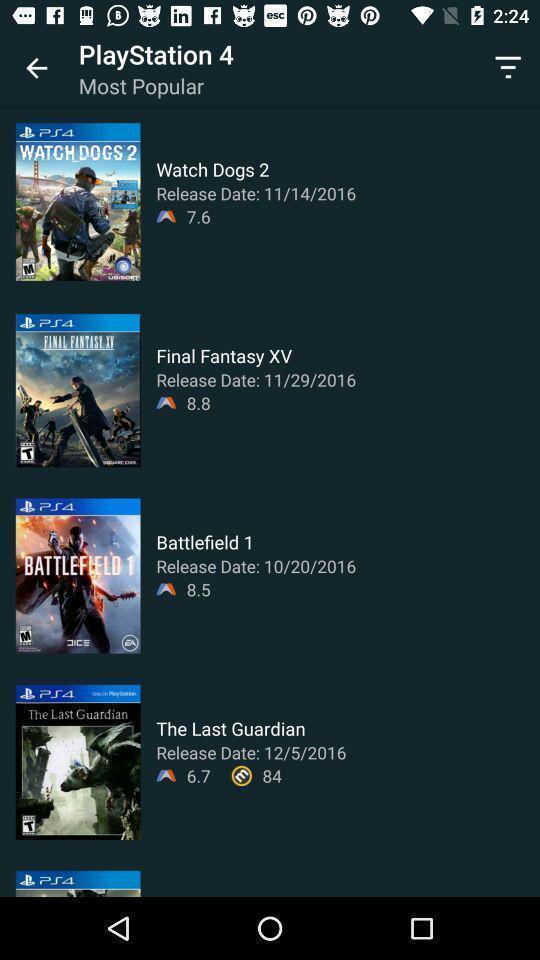Provide a detailed account of this screenshot. Page showing multiple videos on app. 